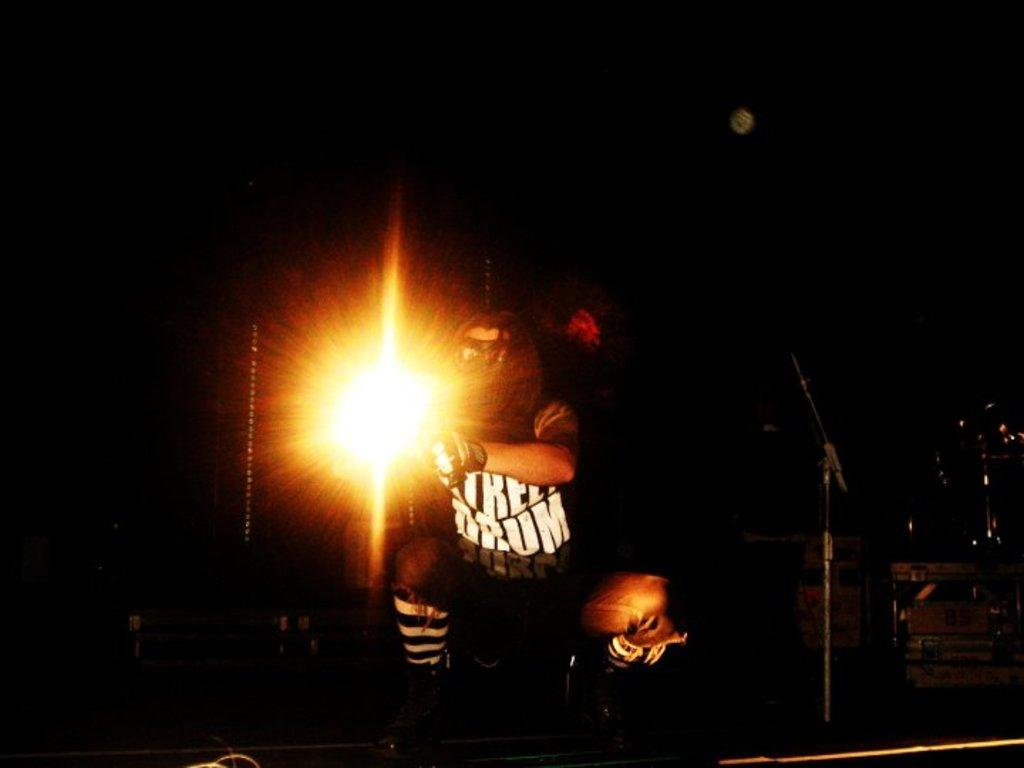What is the main subject of the image? There is a person standing in the center of the image. What is the person holding in the image? The person is holding a light. What can be seen in the background of the image? There is a musical instrument and another light visible in the background of the image. How much coal is being used by the person in the image? There is no coal present in the image, so it cannot be determined how much coal is being used. 